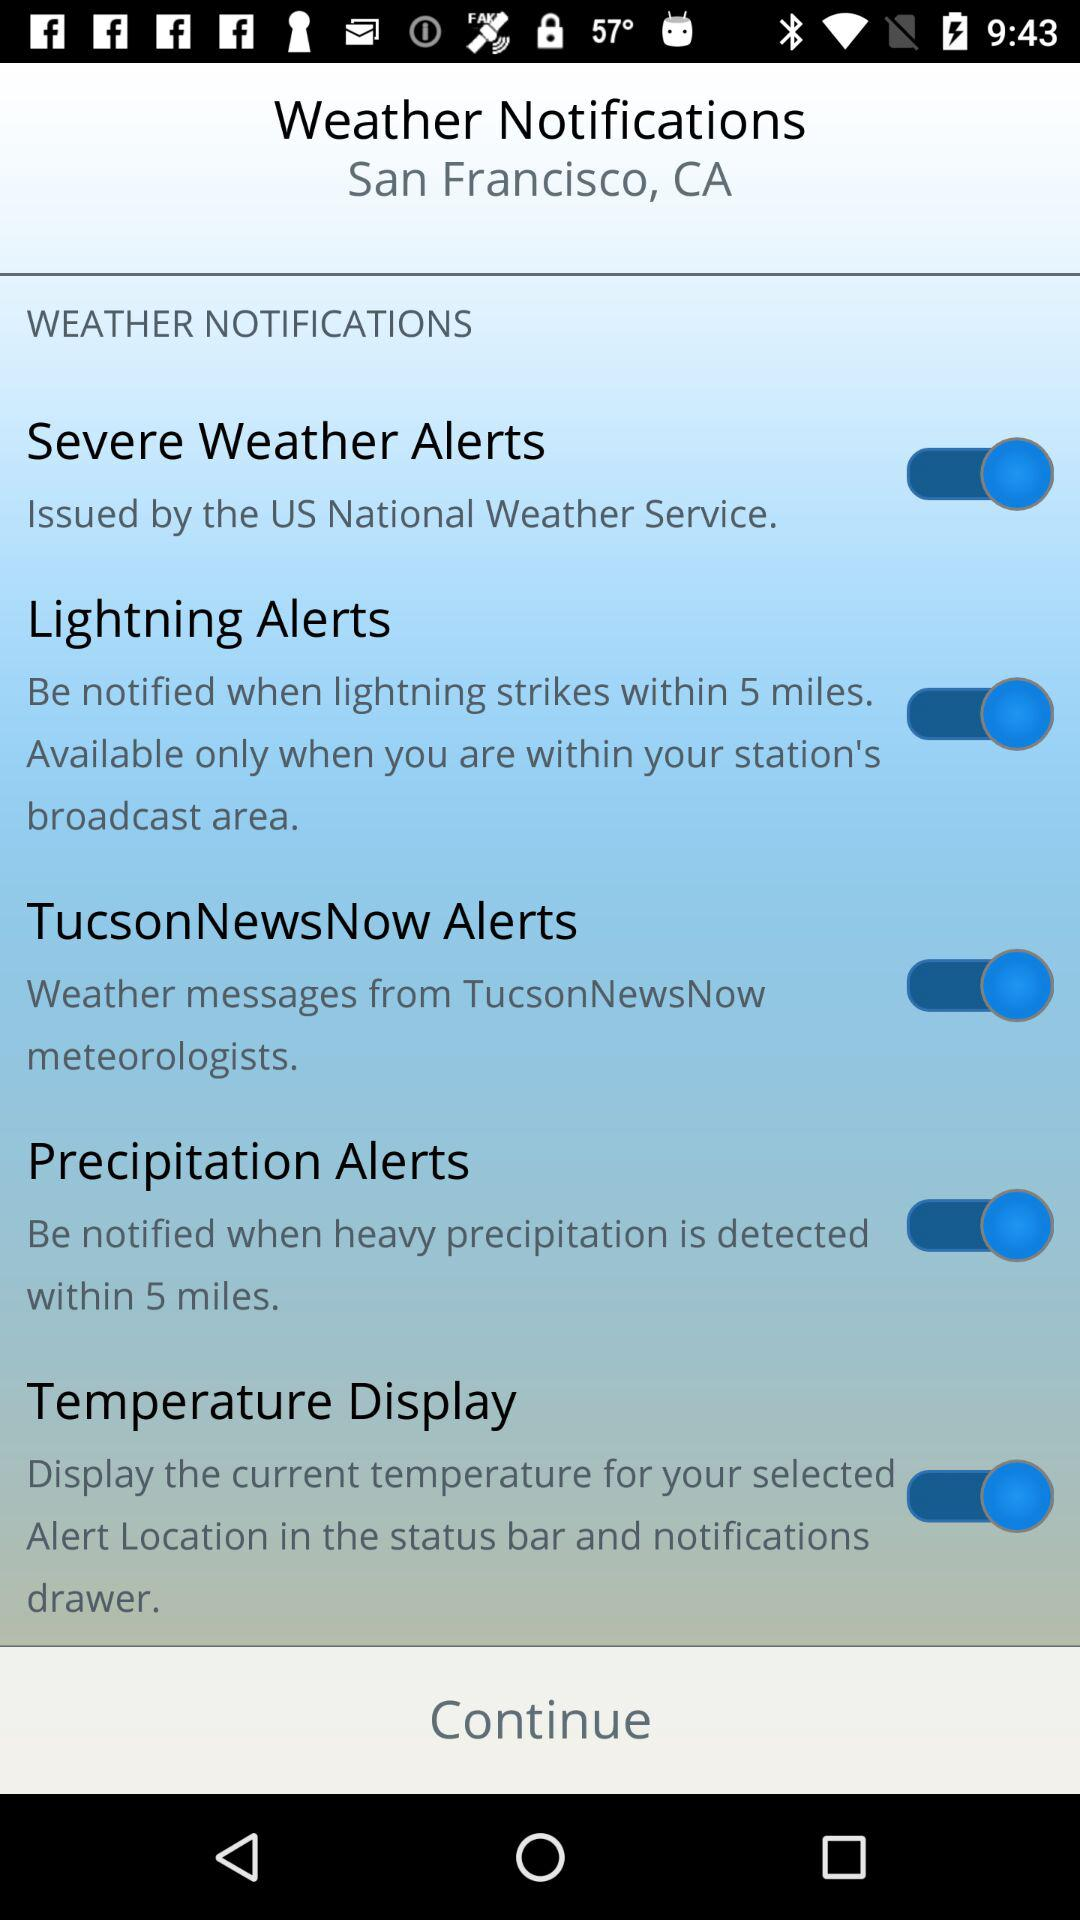Severe weather alerts were issued by which service? Severe weather alerts were issued by the US National Weather Service. 